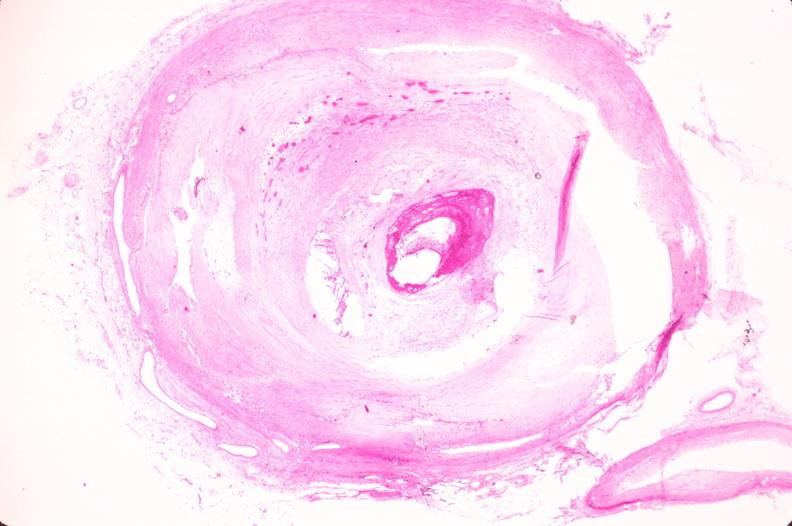what is present?
Answer the question using a single word or phrase. Vasculature 